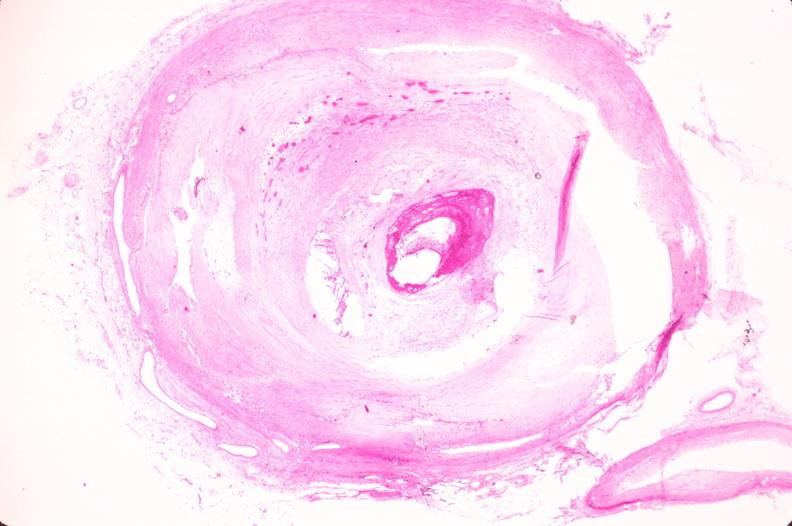what is present?
Answer the question using a single word or phrase. Vasculature 